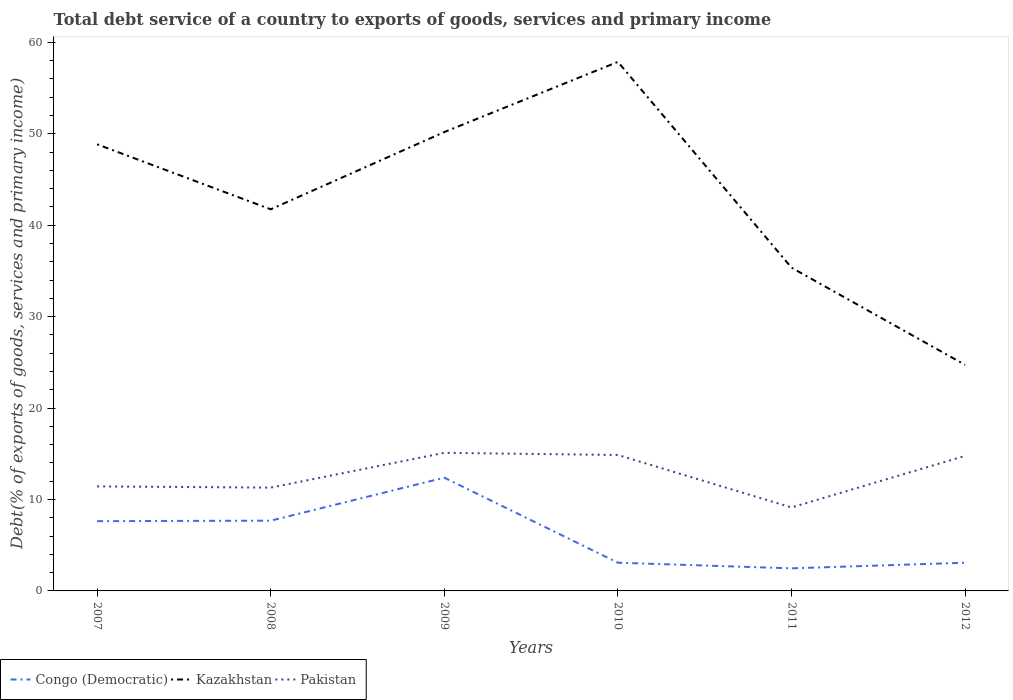Does the line corresponding to Pakistan intersect with the line corresponding to Kazakhstan?
Make the answer very short. No. Across all years, what is the maximum total debt service in Kazakhstan?
Keep it short and to the point. 24.73. In which year was the total debt service in Kazakhstan maximum?
Provide a short and direct response. 2012. What is the total total debt service in Pakistan in the graph?
Your response must be concise. 2.3. What is the difference between the highest and the second highest total debt service in Kazakhstan?
Your answer should be compact. 33.14. What is the difference between two consecutive major ticks on the Y-axis?
Your answer should be very brief. 10. What is the title of the graph?
Your answer should be compact. Total debt service of a country to exports of goods, services and primary income. Does "Kyrgyz Republic" appear as one of the legend labels in the graph?
Keep it short and to the point. No. What is the label or title of the X-axis?
Make the answer very short. Years. What is the label or title of the Y-axis?
Make the answer very short. Debt(% of exports of goods, services and primary income). What is the Debt(% of exports of goods, services and primary income) of Congo (Democratic) in 2007?
Ensure brevity in your answer.  7.63. What is the Debt(% of exports of goods, services and primary income) in Kazakhstan in 2007?
Your answer should be compact. 48.85. What is the Debt(% of exports of goods, services and primary income) in Pakistan in 2007?
Offer a terse response. 11.43. What is the Debt(% of exports of goods, services and primary income) of Congo (Democratic) in 2008?
Ensure brevity in your answer.  7.68. What is the Debt(% of exports of goods, services and primary income) of Kazakhstan in 2008?
Keep it short and to the point. 41.75. What is the Debt(% of exports of goods, services and primary income) of Pakistan in 2008?
Ensure brevity in your answer.  11.3. What is the Debt(% of exports of goods, services and primary income) in Congo (Democratic) in 2009?
Provide a succinct answer. 12.39. What is the Debt(% of exports of goods, services and primary income) of Kazakhstan in 2009?
Your response must be concise. 50.19. What is the Debt(% of exports of goods, services and primary income) of Pakistan in 2009?
Provide a succinct answer. 15.11. What is the Debt(% of exports of goods, services and primary income) of Congo (Democratic) in 2010?
Give a very brief answer. 3.09. What is the Debt(% of exports of goods, services and primary income) in Kazakhstan in 2010?
Offer a very short reply. 57.87. What is the Debt(% of exports of goods, services and primary income) of Pakistan in 2010?
Provide a succinct answer. 14.87. What is the Debt(% of exports of goods, services and primary income) of Congo (Democratic) in 2011?
Your answer should be very brief. 2.47. What is the Debt(% of exports of goods, services and primary income) of Kazakhstan in 2011?
Your answer should be compact. 35.36. What is the Debt(% of exports of goods, services and primary income) of Pakistan in 2011?
Provide a succinct answer. 9.13. What is the Debt(% of exports of goods, services and primary income) in Congo (Democratic) in 2012?
Your answer should be very brief. 3.08. What is the Debt(% of exports of goods, services and primary income) of Kazakhstan in 2012?
Offer a terse response. 24.73. What is the Debt(% of exports of goods, services and primary income) of Pakistan in 2012?
Offer a very short reply. 14.77. Across all years, what is the maximum Debt(% of exports of goods, services and primary income) in Congo (Democratic)?
Your answer should be compact. 12.39. Across all years, what is the maximum Debt(% of exports of goods, services and primary income) of Kazakhstan?
Offer a very short reply. 57.87. Across all years, what is the maximum Debt(% of exports of goods, services and primary income) in Pakistan?
Keep it short and to the point. 15.11. Across all years, what is the minimum Debt(% of exports of goods, services and primary income) in Congo (Democratic)?
Offer a very short reply. 2.47. Across all years, what is the minimum Debt(% of exports of goods, services and primary income) of Kazakhstan?
Keep it short and to the point. 24.73. Across all years, what is the minimum Debt(% of exports of goods, services and primary income) of Pakistan?
Offer a very short reply. 9.13. What is the total Debt(% of exports of goods, services and primary income) of Congo (Democratic) in the graph?
Your answer should be compact. 36.34. What is the total Debt(% of exports of goods, services and primary income) of Kazakhstan in the graph?
Make the answer very short. 258.75. What is the total Debt(% of exports of goods, services and primary income) of Pakistan in the graph?
Offer a terse response. 76.61. What is the difference between the Debt(% of exports of goods, services and primary income) of Congo (Democratic) in 2007 and that in 2008?
Your answer should be very brief. -0.05. What is the difference between the Debt(% of exports of goods, services and primary income) of Kazakhstan in 2007 and that in 2008?
Offer a very short reply. 7.11. What is the difference between the Debt(% of exports of goods, services and primary income) of Pakistan in 2007 and that in 2008?
Ensure brevity in your answer.  0.13. What is the difference between the Debt(% of exports of goods, services and primary income) of Congo (Democratic) in 2007 and that in 2009?
Your answer should be compact. -4.75. What is the difference between the Debt(% of exports of goods, services and primary income) in Kazakhstan in 2007 and that in 2009?
Make the answer very short. -1.34. What is the difference between the Debt(% of exports of goods, services and primary income) in Pakistan in 2007 and that in 2009?
Give a very brief answer. -3.67. What is the difference between the Debt(% of exports of goods, services and primary income) of Congo (Democratic) in 2007 and that in 2010?
Offer a terse response. 4.55. What is the difference between the Debt(% of exports of goods, services and primary income) of Kazakhstan in 2007 and that in 2010?
Ensure brevity in your answer.  -9.02. What is the difference between the Debt(% of exports of goods, services and primary income) of Pakistan in 2007 and that in 2010?
Provide a short and direct response. -3.43. What is the difference between the Debt(% of exports of goods, services and primary income) of Congo (Democratic) in 2007 and that in 2011?
Your answer should be compact. 5.16. What is the difference between the Debt(% of exports of goods, services and primary income) in Kazakhstan in 2007 and that in 2011?
Your answer should be compact. 13.49. What is the difference between the Debt(% of exports of goods, services and primary income) of Pakistan in 2007 and that in 2011?
Ensure brevity in your answer.  2.3. What is the difference between the Debt(% of exports of goods, services and primary income) of Congo (Democratic) in 2007 and that in 2012?
Make the answer very short. 4.55. What is the difference between the Debt(% of exports of goods, services and primary income) in Kazakhstan in 2007 and that in 2012?
Offer a terse response. 24.13. What is the difference between the Debt(% of exports of goods, services and primary income) in Pakistan in 2007 and that in 2012?
Offer a very short reply. -3.34. What is the difference between the Debt(% of exports of goods, services and primary income) in Congo (Democratic) in 2008 and that in 2009?
Your answer should be very brief. -4.7. What is the difference between the Debt(% of exports of goods, services and primary income) of Kazakhstan in 2008 and that in 2009?
Your answer should be very brief. -8.45. What is the difference between the Debt(% of exports of goods, services and primary income) in Pakistan in 2008 and that in 2009?
Provide a succinct answer. -3.81. What is the difference between the Debt(% of exports of goods, services and primary income) of Congo (Democratic) in 2008 and that in 2010?
Offer a terse response. 4.6. What is the difference between the Debt(% of exports of goods, services and primary income) of Kazakhstan in 2008 and that in 2010?
Offer a terse response. -16.12. What is the difference between the Debt(% of exports of goods, services and primary income) of Pakistan in 2008 and that in 2010?
Your answer should be compact. -3.57. What is the difference between the Debt(% of exports of goods, services and primary income) in Congo (Democratic) in 2008 and that in 2011?
Offer a terse response. 5.21. What is the difference between the Debt(% of exports of goods, services and primary income) of Kazakhstan in 2008 and that in 2011?
Keep it short and to the point. 6.39. What is the difference between the Debt(% of exports of goods, services and primary income) in Pakistan in 2008 and that in 2011?
Your response must be concise. 2.17. What is the difference between the Debt(% of exports of goods, services and primary income) of Congo (Democratic) in 2008 and that in 2012?
Make the answer very short. 4.6. What is the difference between the Debt(% of exports of goods, services and primary income) in Kazakhstan in 2008 and that in 2012?
Your answer should be very brief. 17.02. What is the difference between the Debt(% of exports of goods, services and primary income) in Pakistan in 2008 and that in 2012?
Make the answer very short. -3.47. What is the difference between the Debt(% of exports of goods, services and primary income) of Congo (Democratic) in 2009 and that in 2010?
Provide a succinct answer. 9.3. What is the difference between the Debt(% of exports of goods, services and primary income) in Kazakhstan in 2009 and that in 2010?
Give a very brief answer. -7.67. What is the difference between the Debt(% of exports of goods, services and primary income) in Pakistan in 2009 and that in 2010?
Offer a terse response. 0.24. What is the difference between the Debt(% of exports of goods, services and primary income) of Congo (Democratic) in 2009 and that in 2011?
Give a very brief answer. 9.92. What is the difference between the Debt(% of exports of goods, services and primary income) in Kazakhstan in 2009 and that in 2011?
Provide a succinct answer. 14.83. What is the difference between the Debt(% of exports of goods, services and primary income) in Pakistan in 2009 and that in 2011?
Your answer should be compact. 5.98. What is the difference between the Debt(% of exports of goods, services and primary income) in Congo (Democratic) in 2009 and that in 2012?
Your response must be concise. 9.3. What is the difference between the Debt(% of exports of goods, services and primary income) in Kazakhstan in 2009 and that in 2012?
Give a very brief answer. 25.47. What is the difference between the Debt(% of exports of goods, services and primary income) of Pakistan in 2009 and that in 2012?
Your answer should be compact. 0.33. What is the difference between the Debt(% of exports of goods, services and primary income) in Congo (Democratic) in 2010 and that in 2011?
Offer a terse response. 0.61. What is the difference between the Debt(% of exports of goods, services and primary income) in Kazakhstan in 2010 and that in 2011?
Provide a succinct answer. 22.51. What is the difference between the Debt(% of exports of goods, services and primary income) of Pakistan in 2010 and that in 2011?
Make the answer very short. 5.74. What is the difference between the Debt(% of exports of goods, services and primary income) in Congo (Democratic) in 2010 and that in 2012?
Provide a succinct answer. 0. What is the difference between the Debt(% of exports of goods, services and primary income) in Kazakhstan in 2010 and that in 2012?
Provide a succinct answer. 33.14. What is the difference between the Debt(% of exports of goods, services and primary income) in Pakistan in 2010 and that in 2012?
Your answer should be compact. 0.1. What is the difference between the Debt(% of exports of goods, services and primary income) of Congo (Democratic) in 2011 and that in 2012?
Keep it short and to the point. -0.61. What is the difference between the Debt(% of exports of goods, services and primary income) in Kazakhstan in 2011 and that in 2012?
Offer a very short reply. 10.63. What is the difference between the Debt(% of exports of goods, services and primary income) of Pakistan in 2011 and that in 2012?
Your answer should be compact. -5.64. What is the difference between the Debt(% of exports of goods, services and primary income) in Congo (Democratic) in 2007 and the Debt(% of exports of goods, services and primary income) in Kazakhstan in 2008?
Your response must be concise. -34.11. What is the difference between the Debt(% of exports of goods, services and primary income) in Congo (Democratic) in 2007 and the Debt(% of exports of goods, services and primary income) in Pakistan in 2008?
Give a very brief answer. -3.67. What is the difference between the Debt(% of exports of goods, services and primary income) in Kazakhstan in 2007 and the Debt(% of exports of goods, services and primary income) in Pakistan in 2008?
Your answer should be very brief. 37.55. What is the difference between the Debt(% of exports of goods, services and primary income) in Congo (Democratic) in 2007 and the Debt(% of exports of goods, services and primary income) in Kazakhstan in 2009?
Offer a very short reply. -42.56. What is the difference between the Debt(% of exports of goods, services and primary income) in Congo (Democratic) in 2007 and the Debt(% of exports of goods, services and primary income) in Pakistan in 2009?
Offer a terse response. -7.47. What is the difference between the Debt(% of exports of goods, services and primary income) of Kazakhstan in 2007 and the Debt(% of exports of goods, services and primary income) of Pakistan in 2009?
Keep it short and to the point. 33.75. What is the difference between the Debt(% of exports of goods, services and primary income) in Congo (Democratic) in 2007 and the Debt(% of exports of goods, services and primary income) in Kazakhstan in 2010?
Ensure brevity in your answer.  -50.24. What is the difference between the Debt(% of exports of goods, services and primary income) of Congo (Democratic) in 2007 and the Debt(% of exports of goods, services and primary income) of Pakistan in 2010?
Your response must be concise. -7.24. What is the difference between the Debt(% of exports of goods, services and primary income) in Kazakhstan in 2007 and the Debt(% of exports of goods, services and primary income) in Pakistan in 2010?
Your answer should be compact. 33.98. What is the difference between the Debt(% of exports of goods, services and primary income) of Congo (Democratic) in 2007 and the Debt(% of exports of goods, services and primary income) of Kazakhstan in 2011?
Provide a succinct answer. -27.73. What is the difference between the Debt(% of exports of goods, services and primary income) in Congo (Democratic) in 2007 and the Debt(% of exports of goods, services and primary income) in Pakistan in 2011?
Provide a succinct answer. -1.5. What is the difference between the Debt(% of exports of goods, services and primary income) in Kazakhstan in 2007 and the Debt(% of exports of goods, services and primary income) in Pakistan in 2011?
Your answer should be very brief. 39.72. What is the difference between the Debt(% of exports of goods, services and primary income) of Congo (Democratic) in 2007 and the Debt(% of exports of goods, services and primary income) of Kazakhstan in 2012?
Make the answer very short. -17.09. What is the difference between the Debt(% of exports of goods, services and primary income) of Congo (Democratic) in 2007 and the Debt(% of exports of goods, services and primary income) of Pakistan in 2012?
Keep it short and to the point. -7.14. What is the difference between the Debt(% of exports of goods, services and primary income) in Kazakhstan in 2007 and the Debt(% of exports of goods, services and primary income) in Pakistan in 2012?
Give a very brief answer. 34.08. What is the difference between the Debt(% of exports of goods, services and primary income) of Congo (Democratic) in 2008 and the Debt(% of exports of goods, services and primary income) of Kazakhstan in 2009?
Provide a short and direct response. -42.51. What is the difference between the Debt(% of exports of goods, services and primary income) of Congo (Democratic) in 2008 and the Debt(% of exports of goods, services and primary income) of Pakistan in 2009?
Ensure brevity in your answer.  -7.42. What is the difference between the Debt(% of exports of goods, services and primary income) of Kazakhstan in 2008 and the Debt(% of exports of goods, services and primary income) of Pakistan in 2009?
Give a very brief answer. 26.64. What is the difference between the Debt(% of exports of goods, services and primary income) in Congo (Democratic) in 2008 and the Debt(% of exports of goods, services and primary income) in Kazakhstan in 2010?
Give a very brief answer. -50.19. What is the difference between the Debt(% of exports of goods, services and primary income) in Congo (Democratic) in 2008 and the Debt(% of exports of goods, services and primary income) in Pakistan in 2010?
Your response must be concise. -7.19. What is the difference between the Debt(% of exports of goods, services and primary income) in Kazakhstan in 2008 and the Debt(% of exports of goods, services and primary income) in Pakistan in 2010?
Provide a succinct answer. 26.88. What is the difference between the Debt(% of exports of goods, services and primary income) of Congo (Democratic) in 2008 and the Debt(% of exports of goods, services and primary income) of Kazakhstan in 2011?
Provide a short and direct response. -27.68. What is the difference between the Debt(% of exports of goods, services and primary income) of Congo (Democratic) in 2008 and the Debt(% of exports of goods, services and primary income) of Pakistan in 2011?
Give a very brief answer. -1.45. What is the difference between the Debt(% of exports of goods, services and primary income) in Kazakhstan in 2008 and the Debt(% of exports of goods, services and primary income) in Pakistan in 2011?
Ensure brevity in your answer.  32.61. What is the difference between the Debt(% of exports of goods, services and primary income) of Congo (Democratic) in 2008 and the Debt(% of exports of goods, services and primary income) of Kazakhstan in 2012?
Make the answer very short. -17.04. What is the difference between the Debt(% of exports of goods, services and primary income) in Congo (Democratic) in 2008 and the Debt(% of exports of goods, services and primary income) in Pakistan in 2012?
Offer a very short reply. -7.09. What is the difference between the Debt(% of exports of goods, services and primary income) in Kazakhstan in 2008 and the Debt(% of exports of goods, services and primary income) in Pakistan in 2012?
Ensure brevity in your answer.  26.97. What is the difference between the Debt(% of exports of goods, services and primary income) of Congo (Democratic) in 2009 and the Debt(% of exports of goods, services and primary income) of Kazakhstan in 2010?
Your answer should be very brief. -45.48. What is the difference between the Debt(% of exports of goods, services and primary income) of Congo (Democratic) in 2009 and the Debt(% of exports of goods, services and primary income) of Pakistan in 2010?
Your answer should be very brief. -2.48. What is the difference between the Debt(% of exports of goods, services and primary income) in Kazakhstan in 2009 and the Debt(% of exports of goods, services and primary income) in Pakistan in 2010?
Make the answer very short. 35.33. What is the difference between the Debt(% of exports of goods, services and primary income) in Congo (Democratic) in 2009 and the Debt(% of exports of goods, services and primary income) in Kazakhstan in 2011?
Give a very brief answer. -22.97. What is the difference between the Debt(% of exports of goods, services and primary income) of Congo (Democratic) in 2009 and the Debt(% of exports of goods, services and primary income) of Pakistan in 2011?
Your answer should be very brief. 3.26. What is the difference between the Debt(% of exports of goods, services and primary income) of Kazakhstan in 2009 and the Debt(% of exports of goods, services and primary income) of Pakistan in 2011?
Provide a succinct answer. 41.06. What is the difference between the Debt(% of exports of goods, services and primary income) in Congo (Democratic) in 2009 and the Debt(% of exports of goods, services and primary income) in Kazakhstan in 2012?
Offer a very short reply. -12.34. What is the difference between the Debt(% of exports of goods, services and primary income) in Congo (Democratic) in 2009 and the Debt(% of exports of goods, services and primary income) in Pakistan in 2012?
Provide a short and direct response. -2.38. What is the difference between the Debt(% of exports of goods, services and primary income) in Kazakhstan in 2009 and the Debt(% of exports of goods, services and primary income) in Pakistan in 2012?
Offer a very short reply. 35.42. What is the difference between the Debt(% of exports of goods, services and primary income) of Congo (Democratic) in 2010 and the Debt(% of exports of goods, services and primary income) of Kazakhstan in 2011?
Give a very brief answer. -32.28. What is the difference between the Debt(% of exports of goods, services and primary income) in Congo (Democratic) in 2010 and the Debt(% of exports of goods, services and primary income) in Pakistan in 2011?
Ensure brevity in your answer.  -6.05. What is the difference between the Debt(% of exports of goods, services and primary income) in Kazakhstan in 2010 and the Debt(% of exports of goods, services and primary income) in Pakistan in 2011?
Offer a very short reply. 48.74. What is the difference between the Debt(% of exports of goods, services and primary income) of Congo (Democratic) in 2010 and the Debt(% of exports of goods, services and primary income) of Kazakhstan in 2012?
Offer a terse response. -21.64. What is the difference between the Debt(% of exports of goods, services and primary income) of Congo (Democratic) in 2010 and the Debt(% of exports of goods, services and primary income) of Pakistan in 2012?
Keep it short and to the point. -11.69. What is the difference between the Debt(% of exports of goods, services and primary income) in Kazakhstan in 2010 and the Debt(% of exports of goods, services and primary income) in Pakistan in 2012?
Give a very brief answer. 43.1. What is the difference between the Debt(% of exports of goods, services and primary income) in Congo (Democratic) in 2011 and the Debt(% of exports of goods, services and primary income) in Kazakhstan in 2012?
Offer a terse response. -22.26. What is the difference between the Debt(% of exports of goods, services and primary income) of Congo (Democratic) in 2011 and the Debt(% of exports of goods, services and primary income) of Pakistan in 2012?
Keep it short and to the point. -12.3. What is the difference between the Debt(% of exports of goods, services and primary income) in Kazakhstan in 2011 and the Debt(% of exports of goods, services and primary income) in Pakistan in 2012?
Keep it short and to the point. 20.59. What is the average Debt(% of exports of goods, services and primary income) of Congo (Democratic) per year?
Make the answer very short. 6.06. What is the average Debt(% of exports of goods, services and primary income) of Kazakhstan per year?
Keep it short and to the point. 43.12. What is the average Debt(% of exports of goods, services and primary income) in Pakistan per year?
Your answer should be compact. 12.77. In the year 2007, what is the difference between the Debt(% of exports of goods, services and primary income) in Congo (Democratic) and Debt(% of exports of goods, services and primary income) in Kazakhstan?
Offer a very short reply. -41.22. In the year 2007, what is the difference between the Debt(% of exports of goods, services and primary income) of Congo (Democratic) and Debt(% of exports of goods, services and primary income) of Pakistan?
Provide a short and direct response. -3.8. In the year 2007, what is the difference between the Debt(% of exports of goods, services and primary income) of Kazakhstan and Debt(% of exports of goods, services and primary income) of Pakistan?
Provide a short and direct response. 37.42. In the year 2008, what is the difference between the Debt(% of exports of goods, services and primary income) of Congo (Democratic) and Debt(% of exports of goods, services and primary income) of Kazakhstan?
Offer a very short reply. -34.06. In the year 2008, what is the difference between the Debt(% of exports of goods, services and primary income) of Congo (Democratic) and Debt(% of exports of goods, services and primary income) of Pakistan?
Your answer should be compact. -3.62. In the year 2008, what is the difference between the Debt(% of exports of goods, services and primary income) of Kazakhstan and Debt(% of exports of goods, services and primary income) of Pakistan?
Offer a very short reply. 30.44. In the year 2009, what is the difference between the Debt(% of exports of goods, services and primary income) in Congo (Democratic) and Debt(% of exports of goods, services and primary income) in Kazakhstan?
Provide a succinct answer. -37.81. In the year 2009, what is the difference between the Debt(% of exports of goods, services and primary income) in Congo (Democratic) and Debt(% of exports of goods, services and primary income) in Pakistan?
Ensure brevity in your answer.  -2.72. In the year 2009, what is the difference between the Debt(% of exports of goods, services and primary income) of Kazakhstan and Debt(% of exports of goods, services and primary income) of Pakistan?
Provide a short and direct response. 35.09. In the year 2010, what is the difference between the Debt(% of exports of goods, services and primary income) in Congo (Democratic) and Debt(% of exports of goods, services and primary income) in Kazakhstan?
Make the answer very short. -54.78. In the year 2010, what is the difference between the Debt(% of exports of goods, services and primary income) in Congo (Democratic) and Debt(% of exports of goods, services and primary income) in Pakistan?
Offer a terse response. -11.78. In the year 2010, what is the difference between the Debt(% of exports of goods, services and primary income) of Kazakhstan and Debt(% of exports of goods, services and primary income) of Pakistan?
Your response must be concise. 43. In the year 2011, what is the difference between the Debt(% of exports of goods, services and primary income) of Congo (Democratic) and Debt(% of exports of goods, services and primary income) of Kazakhstan?
Offer a very short reply. -32.89. In the year 2011, what is the difference between the Debt(% of exports of goods, services and primary income) of Congo (Democratic) and Debt(% of exports of goods, services and primary income) of Pakistan?
Give a very brief answer. -6.66. In the year 2011, what is the difference between the Debt(% of exports of goods, services and primary income) of Kazakhstan and Debt(% of exports of goods, services and primary income) of Pakistan?
Provide a succinct answer. 26.23. In the year 2012, what is the difference between the Debt(% of exports of goods, services and primary income) of Congo (Democratic) and Debt(% of exports of goods, services and primary income) of Kazakhstan?
Ensure brevity in your answer.  -21.64. In the year 2012, what is the difference between the Debt(% of exports of goods, services and primary income) in Congo (Democratic) and Debt(% of exports of goods, services and primary income) in Pakistan?
Your answer should be compact. -11.69. In the year 2012, what is the difference between the Debt(% of exports of goods, services and primary income) in Kazakhstan and Debt(% of exports of goods, services and primary income) in Pakistan?
Ensure brevity in your answer.  9.96. What is the ratio of the Debt(% of exports of goods, services and primary income) of Congo (Democratic) in 2007 to that in 2008?
Offer a terse response. 0.99. What is the ratio of the Debt(% of exports of goods, services and primary income) of Kazakhstan in 2007 to that in 2008?
Make the answer very short. 1.17. What is the ratio of the Debt(% of exports of goods, services and primary income) in Pakistan in 2007 to that in 2008?
Provide a succinct answer. 1.01. What is the ratio of the Debt(% of exports of goods, services and primary income) in Congo (Democratic) in 2007 to that in 2009?
Your answer should be very brief. 0.62. What is the ratio of the Debt(% of exports of goods, services and primary income) in Kazakhstan in 2007 to that in 2009?
Your answer should be compact. 0.97. What is the ratio of the Debt(% of exports of goods, services and primary income) of Pakistan in 2007 to that in 2009?
Provide a succinct answer. 0.76. What is the ratio of the Debt(% of exports of goods, services and primary income) of Congo (Democratic) in 2007 to that in 2010?
Ensure brevity in your answer.  2.47. What is the ratio of the Debt(% of exports of goods, services and primary income) of Kazakhstan in 2007 to that in 2010?
Provide a succinct answer. 0.84. What is the ratio of the Debt(% of exports of goods, services and primary income) in Pakistan in 2007 to that in 2010?
Keep it short and to the point. 0.77. What is the ratio of the Debt(% of exports of goods, services and primary income) in Congo (Democratic) in 2007 to that in 2011?
Your answer should be compact. 3.09. What is the ratio of the Debt(% of exports of goods, services and primary income) of Kazakhstan in 2007 to that in 2011?
Offer a very short reply. 1.38. What is the ratio of the Debt(% of exports of goods, services and primary income) of Pakistan in 2007 to that in 2011?
Make the answer very short. 1.25. What is the ratio of the Debt(% of exports of goods, services and primary income) of Congo (Democratic) in 2007 to that in 2012?
Ensure brevity in your answer.  2.47. What is the ratio of the Debt(% of exports of goods, services and primary income) of Kazakhstan in 2007 to that in 2012?
Keep it short and to the point. 1.98. What is the ratio of the Debt(% of exports of goods, services and primary income) of Pakistan in 2007 to that in 2012?
Your answer should be compact. 0.77. What is the ratio of the Debt(% of exports of goods, services and primary income) of Congo (Democratic) in 2008 to that in 2009?
Your response must be concise. 0.62. What is the ratio of the Debt(% of exports of goods, services and primary income) in Kazakhstan in 2008 to that in 2009?
Provide a short and direct response. 0.83. What is the ratio of the Debt(% of exports of goods, services and primary income) of Pakistan in 2008 to that in 2009?
Provide a short and direct response. 0.75. What is the ratio of the Debt(% of exports of goods, services and primary income) in Congo (Democratic) in 2008 to that in 2010?
Your answer should be very brief. 2.49. What is the ratio of the Debt(% of exports of goods, services and primary income) of Kazakhstan in 2008 to that in 2010?
Ensure brevity in your answer.  0.72. What is the ratio of the Debt(% of exports of goods, services and primary income) of Pakistan in 2008 to that in 2010?
Make the answer very short. 0.76. What is the ratio of the Debt(% of exports of goods, services and primary income) of Congo (Democratic) in 2008 to that in 2011?
Ensure brevity in your answer.  3.11. What is the ratio of the Debt(% of exports of goods, services and primary income) of Kazakhstan in 2008 to that in 2011?
Ensure brevity in your answer.  1.18. What is the ratio of the Debt(% of exports of goods, services and primary income) in Pakistan in 2008 to that in 2011?
Ensure brevity in your answer.  1.24. What is the ratio of the Debt(% of exports of goods, services and primary income) in Congo (Democratic) in 2008 to that in 2012?
Give a very brief answer. 2.49. What is the ratio of the Debt(% of exports of goods, services and primary income) of Kazakhstan in 2008 to that in 2012?
Provide a succinct answer. 1.69. What is the ratio of the Debt(% of exports of goods, services and primary income) of Pakistan in 2008 to that in 2012?
Your answer should be compact. 0.77. What is the ratio of the Debt(% of exports of goods, services and primary income) of Congo (Democratic) in 2009 to that in 2010?
Keep it short and to the point. 4.01. What is the ratio of the Debt(% of exports of goods, services and primary income) of Kazakhstan in 2009 to that in 2010?
Offer a terse response. 0.87. What is the ratio of the Debt(% of exports of goods, services and primary income) in Pakistan in 2009 to that in 2010?
Offer a terse response. 1.02. What is the ratio of the Debt(% of exports of goods, services and primary income) in Congo (Democratic) in 2009 to that in 2011?
Your response must be concise. 5.01. What is the ratio of the Debt(% of exports of goods, services and primary income) in Kazakhstan in 2009 to that in 2011?
Your response must be concise. 1.42. What is the ratio of the Debt(% of exports of goods, services and primary income) of Pakistan in 2009 to that in 2011?
Your answer should be very brief. 1.65. What is the ratio of the Debt(% of exports of goods, services and primary income) of Congo (Democratic) in 2009 to that in 2012?
Make the answer very short. 4.02. What is the ratio of the Debt(% of exports of goods, services and primary income) in Kazakhstan in 2009 to that in 2012?
Your answer should be compact. 2.03. What is the ratio of the Debt(% of exports of goods, services and primary income) of Pakistan in 2009 to that in 2012?
Your answer should be compact. 1.02. What is the ratio of the Debt(% of exports of goods, services and primary income) of Congo (Democratic) in 2010 to that in 2011?
Provide a short and direct response. 1.25. What is the ratio of the Debt(% of exports of goods, services and primary income) of Kazakhstan in 2010 to that in 2011?
Your answer should be compact. 1.64. What is the ratio of the Debt(% of exports of goods, services and primary income) in Pakistan in 2010 to that in 2011?
Make the answer very short. 1.63. What is the ratio of the Debt(% of exports of goods, services and primary income) of Congo (Democratic) in 2010 to that in 2012?
Make the answer very short. 1. What is the ratio of the Debt(% of exports of goods, services and primary income) of Kazakhstan in 2010 to that in 2012?
Provide a succinct answer. 2.34. What is the ratio of the Debt(% of exports of goods, services and primary income) in Pakistan in 2010 to that in 2012?
Provide a succinct answer. 1.01. What is the ratio of the Debt(% of exports of goods, services and primary income) in Congo (Democratic) in 2011 to that in 2012?
Provide a short and direct response. 0.8. What is the ratio of the Debt(% of exports of goods, services and primary income) in Kazakhstan in 2011 to that in 2012?
Offer a terse response. 1.43. What is the ratio of the Debt(% of exports of goods, services and primary income) of Pakistan in 2011 to that in 2012?
Provide a short and direct response. 0.62. What is the difference between the highest and the second highest Debt(% of exports of goods, services and primary income) in Congo (Democratic)?
Offer a terse response. 4.7. What is the difference between the highest and the second highest Debt(% of exports of goods, services and primary income) in Kazakhstan?
Provide a succinct answer. 7.67. What is the difference between the highest and the second highest Debt(% of exports of goods, services and primary income) of Pakistan?
Make the answer very short. 0.24. What is the difference between the highest and the lowest Debt(% of exports of goods, services and primary income) in Congo (Democratic)?
Provide a succinct answer. 9.92. What is the difference between the highest and the lowest Debt(% of exports of goods, services and primary income) of Kazakhstan?
Your response must be concise. 33.14. What is the difference between the highest and the lowest Debt(% of exports of goods, services and primary income) of Pakistan?
Offer a very short reply. 5.98. 